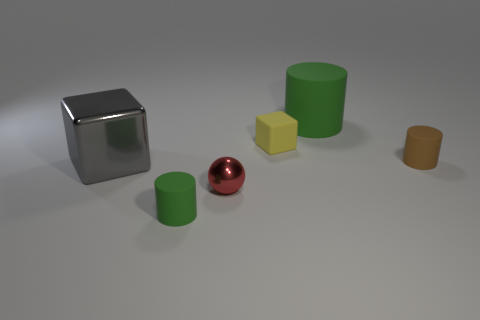Add 1 green cylinders. How many objects exist? 7 Subtract all blocks. How many objects are left? 4 Subtract all cubes. Subtract all tiny yellow cubes. How many objects are left? 3 Add 5 tiny green things. How many tiny green things are left? 6 Add 1 big gray cubes. How many big gray cubes exist? 2 Subtract 1 gray blocks. How many objects are left? 5 